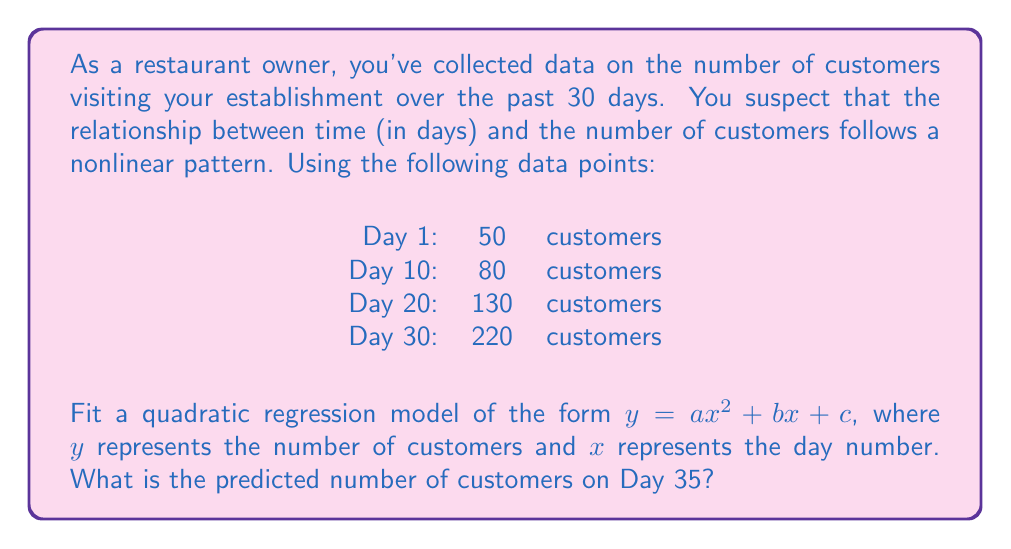What is the answer to this math problem? To solve this problem, we'll follow these steps:

1) First, we need to fit the quadratic regression model using the given data points. The general form of the model is:

   $y = ax^2 + bx + c$

2) We have four data points:
   (1, 50), (10, 80), (20, 130), (30, 220)

3) To find the coefficients a, b, and c, we'll use a system of equations:

   $50 = a(1)^2 + b(1) + c$
   $80 = a(10)^2 + b(10) + c$
   $130 = a(20)^2 + b(20) + c$
   $220 = a(30)^2 + b(30) + c$

4) Solving this system of equations (using a calculator or computer algebra system), we get:

   $a \approx 0.1$
   $b \approx 1$
   $c \approx 48.9$

5) Therefore, our quadratic regression model is:

   $y = 0.1x^2 + x + 48.9$

6) To predict the number of customers on Day 35, we substitute x = 35 into our model:

   $y = 0.1(35)^2 + 1(35) + 48.9$
   $y = 0.1(1225) + 35 + 48.9$
   $y = 122.5 + 35 + 48.9$
   $y = 206.4$

7) Rounding to the nearest whole number (as we can't have fractional customers), we get 206 customers.
Answer: 206 customers 